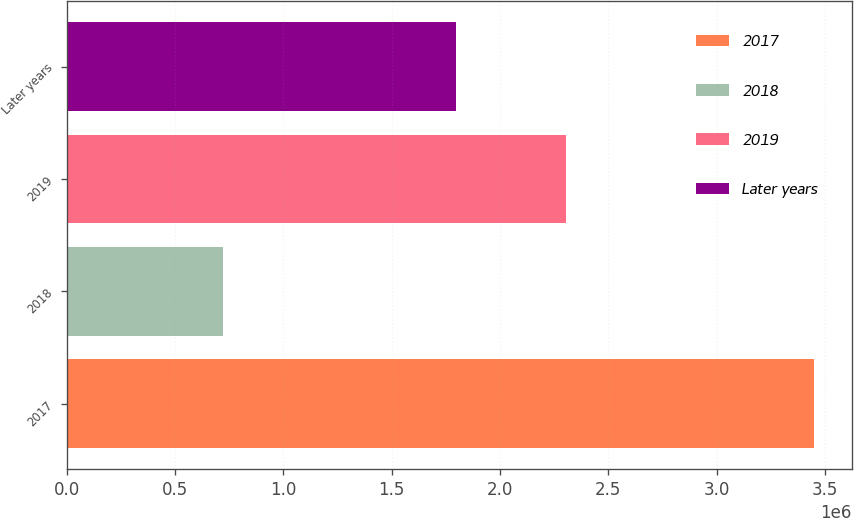Convert chart. <chart><loc_0><loc_0><loc_500><loc_500><bar_chart><fcel>2017<fcel>2018<fcel>2019<fcel>Later years<nl><fcel>3.45242e+06<fcel>719574<fcel>2.30633e+06<fcel>1.79636e+06<nl></chart> 